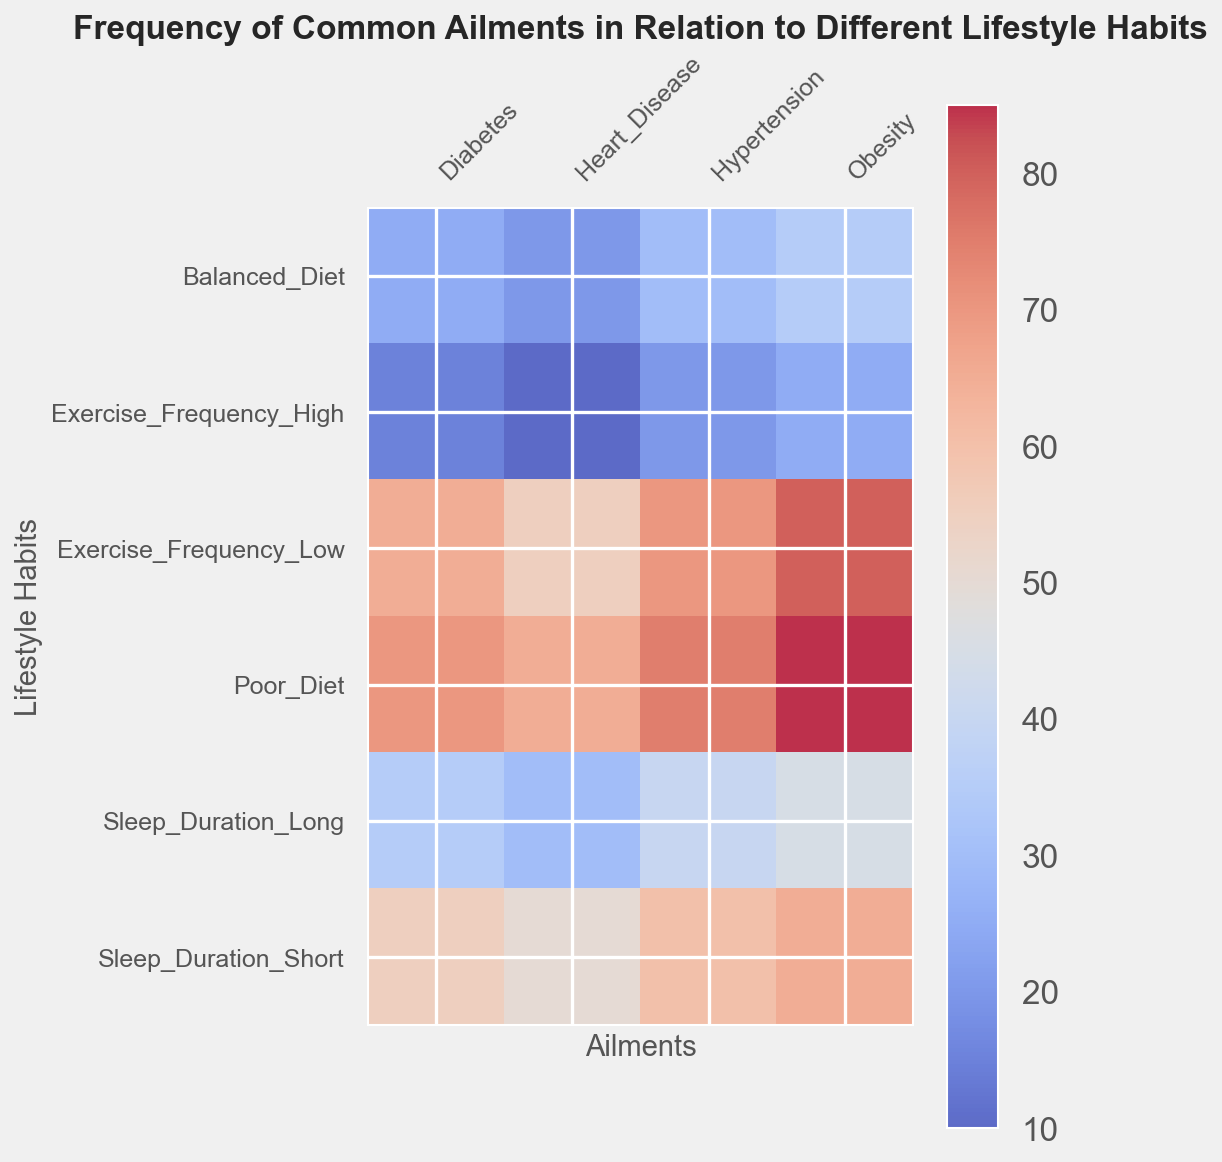Which lifestyle habit has the highest frequency of hypertension? From the heatmap, observe the color intensity for hypertension across different lifestyle habits. The darkest color, indicating the highest frequency, is for Poor_Diet.
Answer: Poor_Diet How does the frequency of diabetes compare between those with high exercise frequency and those with poor diet? Compare the color shades for diabetes under Exercise_Frequency_High and Poor_Diet. The color for Poor_Diet is significantly darker than for Exercise_Frequency_High, indicating a higher frequency.
Answer: Higher in Poor_Diet Which ailment is the most common among those with short sleep duration? Look at the colors corresponding to Sleep_Duration_Short for each ailment. The darkest (most intense) color corresponds to Obesity.
Answer: Obesity What is the difference between the frequency of hypertension in individuals with balanced diets and those with high exercise frequency? Find the frequency values for hypertension under Balanced_Diet (30) and Exercise_Frequency_High (20). The difference is 30 - 20.
Answer: 10 Is the frequency of heart disease higher in individuals with long sleep duration or those with a balanced diet? Compare the color shades for heart disease in Sleep_Duration_Long and Balanced_Diet. Sleep_Duration_Long has a lighter color, indicating a lower frequency.
Answer: Balanced_Diet What is the average frequency of ailments in individuals with a poor diet? Identify the frequencies for Poor_Diet (Hypertension: 75, Diabetes: 70, Obesity: 85, Heart_Disease: 65). Calculate the average: (75 + 70 + 85 + 65) / 4 = 73.75.
Answer: 73.75 Which ailment has the smallest difference in frequency between high and low exercise frequency? Calculate the differences for each ailment:
Hypertension: 70 - 20 = 50
Diabetes: 65 - 15 = 50
Obesity: 80 - 25 = 55
Heart_Disease: 55 - 10 = 45
The smallest difference is for Heart_Disease.
Answer: Heart_Disease What is the sum of the frequencies of diabetes and heart disease for individuals with long sleep duration? Add the frequencies for Sleep_Duration_Long (Diabetes: 35, Heart_Disease: 30). The sum is 35 + 30.
Answer: 65 